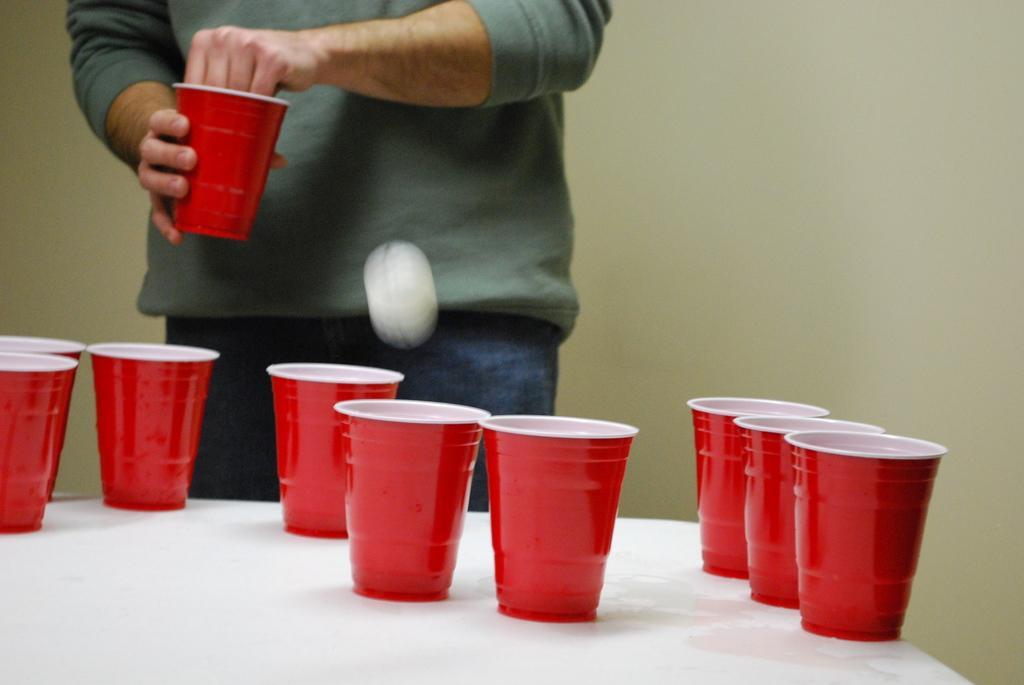Could you give a brief overview of what you see in this image? In this image there are a few plastic cups on a table, in front of the table there is a person standing and holding a cup in his hand. There is a ball in the air. 